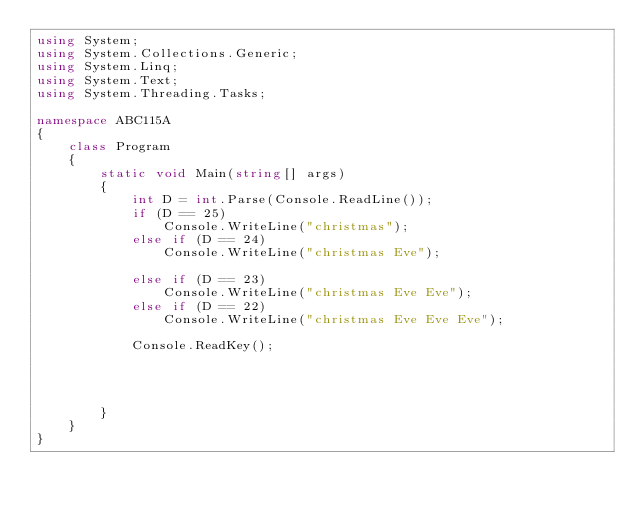<code> <loc_0><loc_0><loc_500><loc_500><_C#_>using System;
using System.Collections.Generic;
using System.Linq;
using System.Text;
using System.Threading.Tasks;

namespace ABC115A
{
    class Program
    {
        static void Main(string[] args)
        {
            int D = int.Parse(Console.ReadLine());
            if (D == 25)
                Console.WriteLine("christmas");
            else if (D == 24)
                Console.WriteLine("christmas Eve");

            else if (D == 23)
                Console.WriteLine("christmas Eve Eve");
            else if (D == 22)
                Console.WriteLine("christmas Eve Eve Eve");

            Console.ReadKey();




        }
    }
}
</code> 